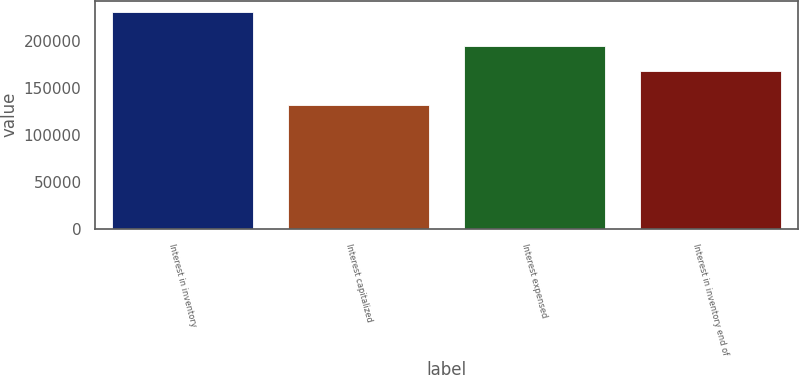Convert chart to OTSL. <chart><loc_0><loc_0><loc_500><loc_500><bar_chart><fcel>Interest in inventory<fcel>Interest capitalized<fcel>Interest expensed<fcel>Interest in inventory end of<nl><fcel>230922<fcel>131444<fcel>194728<fcel>167638<nl></chart> 